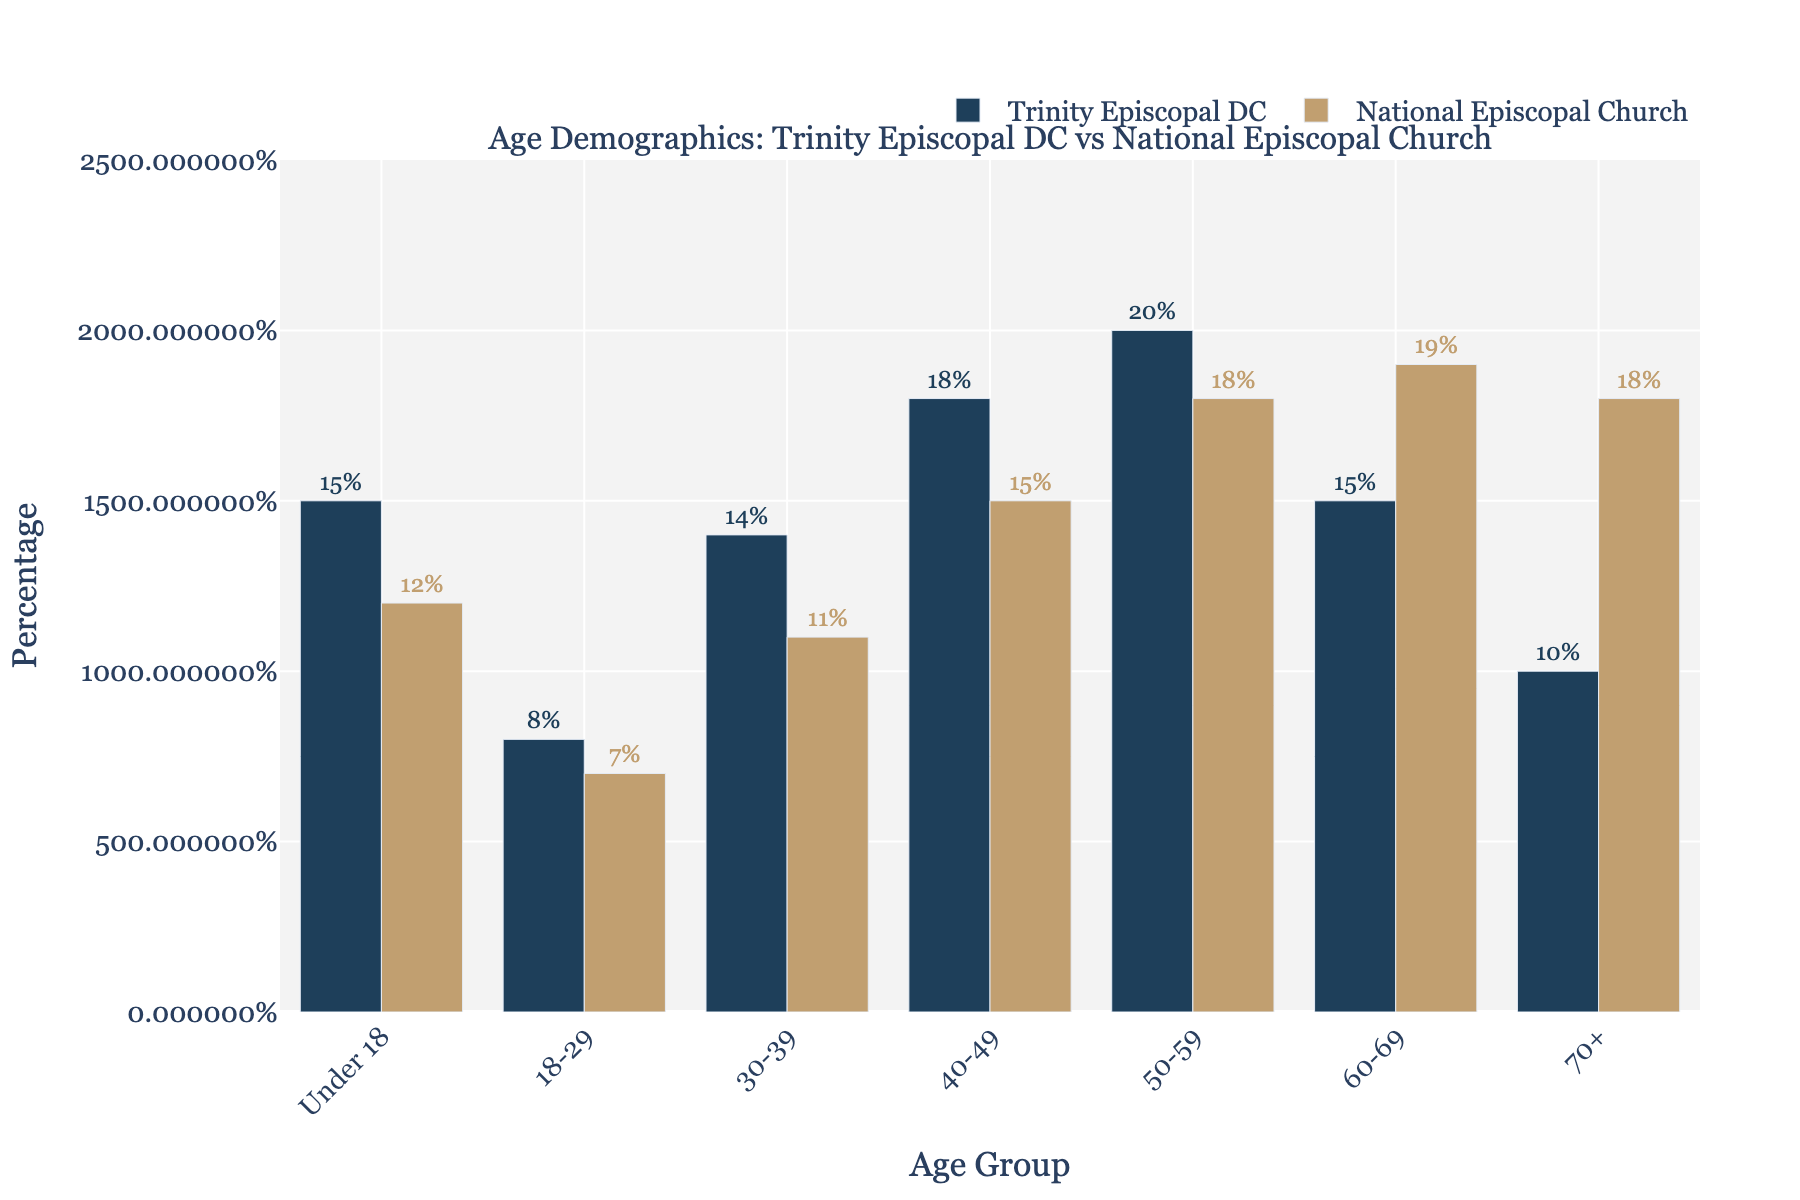What is the age group with the highest percentage in Trinity Episcopal DC? In the figure, the tallest bar representing Trinity Episcopal DC is for the 50-59 age group.
Answer: 50-59 Which age group has a higher percentage in Trinity Episcopal DC compared to the National Episcopal Church? By comparing the heights of the paired bars for each age group, Trinity Episcopal DC has a higher percentage in the 18-29, 30-39, 40-49, and 50-59 age groups.
Answer: 18-29, 30-39, 40-49, 50-59 How does the percentage of congregants aged 70+ in Trinity Episcopal DC compare with the National Episcopal Church? The bar representing the 70+ age group shows that Trinity Episcopal DC has a shorter bar than the National Episcopal Church, indicating a lower percentage. Specifically, 10% for Trinity versus 18% nationally.
Answer: Lower, 10% vs 18% What is the total percentage of congregants under 50 years old in Trinity Episcopal DC? To get the total percentage of congregants under 50 years old in Trinity Episcopal DC, sum the percentages for the under 18, 18-29, 30-39, and 40-49 age groups: 15% + 8% + 14% + 18% = 55%.
Answer: 55% Which age group has the largest difference in percentage between Trinity Episcopal DC and the National Episcopal Church? By examining the difference in bar heights for each age group, the largest difference is seen in the 70+ age group, with a difference of 8 percentage points (18% nationally - 10% for Trinity).
Answer: 70+ In the age group 60-69, how much higher is the percentage of the National Episcopal Church compared to Trinity Episcopal DC? The bar for the 60-69 age group shows 19% for the National Episcopal Church and 15% for Trinity Episcopal DC, so the difference is 4 percentage points higher nationally.
Answer: 4% What is the combined percentage of congregants aged 50-69 in Trinity Episcopal DC? Sum the percentages of the 50-59 and 60-69 age groups for Trinity Episcopal DC: 20% + 15% = 35%.
Answer: 35% Among the age groups under 60 years old, which age group has the least representation in both Trinity Episcopal DC and the National Episcopal Church? Comparing the bars for age groups under 60, the 18-29 age group has the lowest percentages in both cases, with 8% for Trinity and 7% for the national church.
Answer: 18-29 